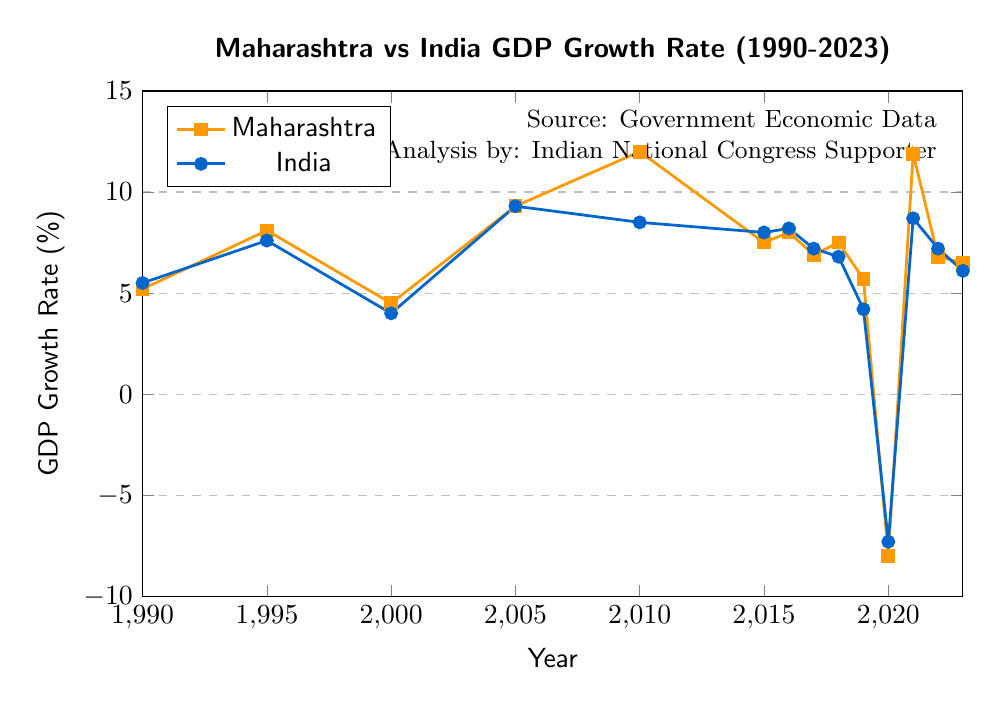What year did Maharashtra have the highest GDP growth rate, and how does this compare to India's growth rate in the same year? From the figure, Maharashtra's highest GDP growth rate was in 2010 at 12.0%. In the same year, India's growth rate was 8.5%.
Answer: 2010, 12.0% for Maharashtra, 8.5% for India In which year did Maharashtra experience negative GDP growth and what was the corresponding growth rate for India? The chart shows that Maharashtra experienced negative GDP growth in 2020 with a rate of -8.0%. During that same year, India's GDP growth rate was also negative at -7.3%.
Answer: 2020, -8.0% for Maharashtra, -7.3% for India Compare the GDP growth rates of Maharashtra and India in 2005. Are they different or the same? In 2005, both Maharashtra and India had the same GDP growth rate of 9.3% as indicated by their data points on the chart.
Answer: Same, 9.3% What was the average GDP growth rate for Maharashtra from 1990 to 2023? To find the average, add up all the GDP growth rates for Maharashtra from the years provided and divide by the number of years: (5.2+8.1+4.5+9.3+12.0+7.5+8.0+6.9+7.5+5.7+-8.0+11.9+6.8+6.5)/14 = 6.42%.
Answer: 6.42% In which year was the difference between Maharashtra's and India's GDP growth rates the greatest, and what was this difference? First, find the differences for each year, then identify the maximum. The differences are: 1990 (-0.3), 1995 (0.5), 2000 (0.5), 2005 (0), 2010 (3.5), 2015 (-0.5), 2016 (-0.2), 2017 (-0.3), 2018 (0.7), 2019 (1.5), 2020 (-0.7), 2021 (3.2), 2022 (-0.4), 2023 (0.4). The greatest difference is in 2010 with a difference of 3.5%.
Answer: 2010, 3.5% What's the trend of Maharashtra's GDP growth rate from 2019 to 2023, and how does it differ from India's trend during the same period? From 2019 to 2023, Maharashtra's GDP growth rate has fluctuated, initially dropping significantly in 2020 and then increasing, though less consistently. India also dropped in 2020, but the subsequent yearly changes show less fluctuation.
Answer: Fluctuating for Maharashtra; less fluctuation for India Which year had the smallest difference in GDP growth rates between Maharashtra and India after 2010? Reviewing the differences post-2010: 2015 (-0.5), 2016 (-0.2), 2017 (-0.3), 2018 (0.7), 2019 (1.5), 2020 (-0.7), 2021 (3.2), 2022 (-0.4), 2023 (0.4). The smallest difference was in 2016 at -0.2%.
Answer: 2016, -0.2% In which years did Maharashtra's GDP growth rate surpass that of India? The chart indicates that Maharashtra's growth surpassed India in the years: 2000, 2010, 2018, 2019, 2021, and 2023 based on higher data points for Maharashtra in those years.
Answer: 2000, 2010, 2018, 2019, 2021, and 2023 What is the year when both Maharashtra and India had equal GDP growth rates? From the data, 2005 is the only year where both Maharashtra and India had equal GDP growth rates, with both exhibiting a rate of 9.3%.
Answer: 2005 What color represents Maharashtra in the plot? According to the visual attributes used in the chart, Maharashtra is represented with an orange color.
Answer: Orange 